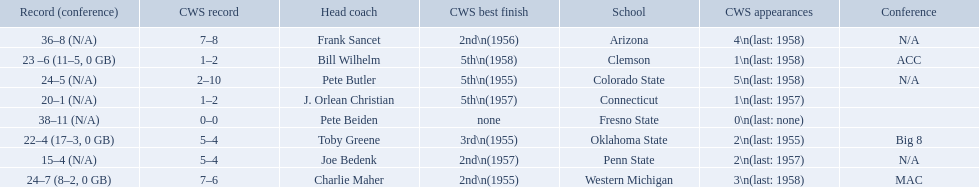Which teams played in the 1959 ncaa university division baseball tournament? Arizona, Clemson, Colorado State, Connecticut, Fresno State, Oklahoma State, Penn State, Western Michigan. Which was the only one to win less than 20 games? Penn State. 